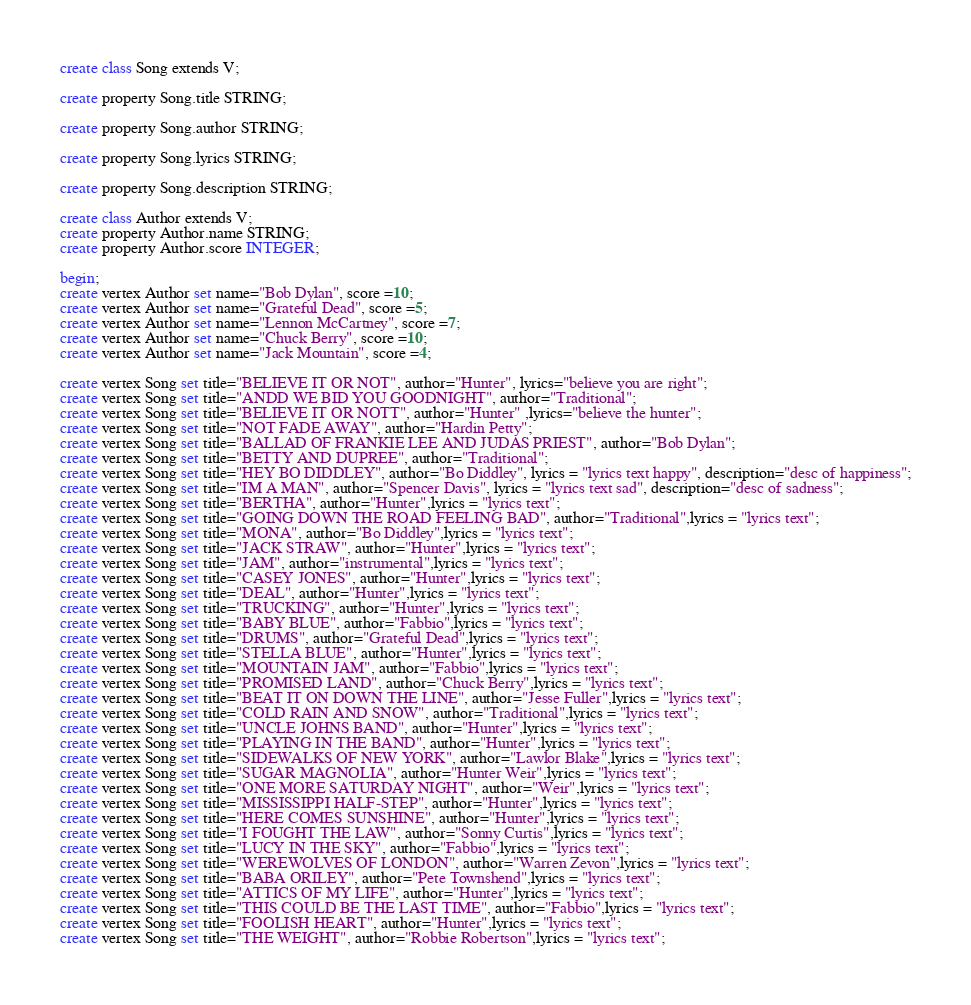<code> <loc_0><loc_0><loc_500><loc_500><_SQL_>create class Song extends V;

create property Song.title STRING;

create property Song.author STRING;

create property Song.lyrics STRING;

create property Song.description STRING;

create class Author extends V;
create property Author.name STRING;
create property Author.score INTEGER;

begin;
create vertex Author set name="Bob Dylan", score =10;
create vertex Author set name="Grateful Dead", score =5;
create vertex Author set name="Lennon McCartney", score =7;
create vertex Author set name="Chuck Berry", score =10;
create vertex Author set name="Jack Mountain", score =4;

create vertex Song set title="BELIEVE IT OR NOT", author="Hunter", lyrics="believe you are right";
create vertex Song set title="ANDD WE BID YOU GOODNIGHT", author="Traditional";
create vertex Song set title="BELIEVE IT OR NOTT", author="Hunter" ,lyrics="believe the hunter";
create vertex Song set title="NOT FADE AWAY", author="Hardin Petty";
create vertex Song set title="BALLAD OF FRANKIE LEE AND JUDAS PRIEST", author="Bob Dylan";
create vertex Song set title="BETTY AND DUPREE", author="Traditional";
create vertex Song set title="HEY BO DIDDLEY", author="Bo Diddley", lyrics = "lyrics text happy", description="desc of happiness";
create vertex Song set title="IM A MAN", author="Spencer Davis", lyrics = "lyrics text sad", description="desc of sadness";
create vertex Song set title="BERTHA", author="Hunter",lyrics = "lyrics text";
create vertex Song set title="GOING DOWN THE ROAD FEELING BAD", author="Traditional",lyrics = "lyrics text";
create vertex Song set title="MONA", author="Bo Diddley",lyrics = "lyrics text";
create vertex Song set title="JACK STRAW", author="Hunter",lyrics = "lyrics text";
create vertex Song set title="JAM", author="instrumental",lyrics = "lyrics text";
create vertex Song set title="CASEY JONES", author="Hunter",lyrics = "lyrics text";
create vertex Song set title="DEAL", author="Hunter",lyrics = "lyrics text";
create vertex Song set title="TRUCKING", author="Hunter",lyrics = "lyrics text";
create vertex Song set title="BABY BLUE", author="Fabbio",lyrics = "lyrics text";
create vertex Song set title="DRUMS", author="Grateful Dead",lyrics = "lyrics text";
create vertex Song set title="STELLA BLUE", author="Hunter",lyrics = "lyrics text";
create vertex Song set title="MOUNTAIN JAM", author="Fabbio",lyrics = "lyrics text";
create vertex Song set title="PROMISED LAND", author="Chuck Berry",lyrics = "lyrics text";
create vertex Song set title="BEAT IT ON DOWN THE LINE", author="Jesse Fuller",lyrics = "lyrics text";
create vertex Song set title="COLD RAIN AND SNOW", author="Traditional",lyrics = "lyrics text";
create vertex Song set title="UNCLE JOHNS BAND", author="Hunter",lyrics = "lyrics text";
create vertex Song set title="PLAYING IN THE BAND", author="Hunter",lyrics = "lyrics text";
create vertex Song set title="SIDEWALKS OF NEW YORK", author="Lawlor Blake",lyrics = "lyrics text";
create vertex Song set title="SUGAR MAGNOLIA", author="Hunter Weir",lyrics = "lyrics text";
create vertex Song set title="ONE MORE SATURDAY NIGHT", author="Weir",lyrics = "lyrics text";
create vertex Song set title="MISSISSIPPI HALF-STEP", author="Hunter",lyrics = "lyrics text";
create vertex Song set title="HERE COMES SUNSHINE", author="Hunter",lyrics = "lyrics text";
create vertex Song set title="I FOUGHT THE LAW", author="Sonny Curtis",lyrics = "lyrics text";
create vertex Song set title="LUCY IN THE SKY", author="Fabbio",lyrics = "lyrics text";
create vertex Song set title="WEREWOLVES OF LONDON", author="Warren Zevon",lyrics = "lyrics text";
create vertex Song set title="BABA ORILEY", author="Pete Townshend",lyrics = "lyrics text";
create vertex Song set title="ATTICS OF MY LIFE", author="Hunter",lyrics = "lyrics text";
create vertex Song set title="THIS COULD BE THE LAST TIME", author="Fabbio",lyrics = "lyrics text";
create vertex Song set title="FOOLISH HEART", author="Hunter",lyrics = "lyrics text";
create vertex Song set title="THE WEIGHT", author="Robbie Robertson",lyrics = "lyrics text";</code> 